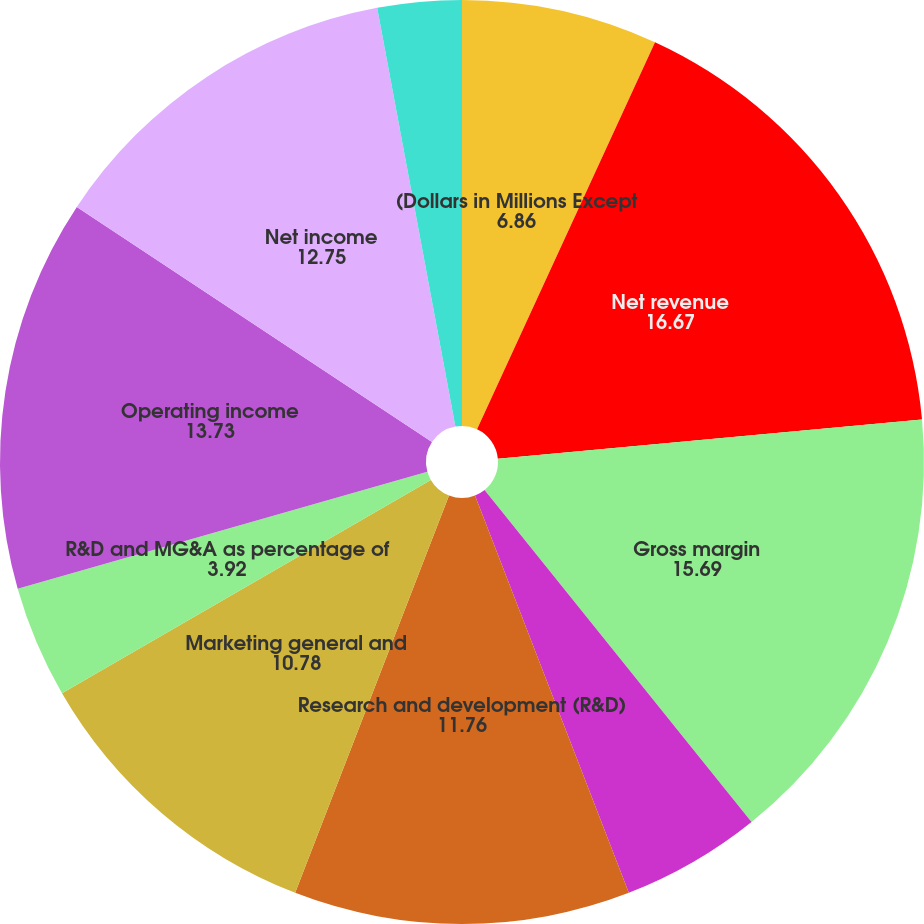<chart> <loc_0><loc_0><loc_500><loc_500><pie_chart><fcel>(Dollars in Millions Except<fcel>Net revenue<fcel>Gross margin<fcel>Gross margin percentage<fcel>Research and development (R&D)<fcel>Marketing general and<fcel>R&D and MG&A as percentage of<fcel>Operating income<fcel>Net income<fcel>Basic<nl><fcel>6.86%<fcel>16.67%<fcel>15.69%<fcel>4.9%<fcel>11.76%<fcel>10.78%<fcel>3.92%<fcel>13.73%<fcel>12.75%<fcel>2.94%<nl></chart> 